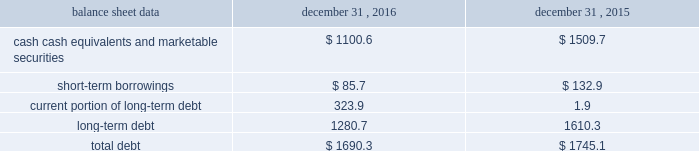Management 2019s discussion and analysis of financial condition and results of operations 2013 ( continued ) ( amounts in millions , except per share amounts ) the effect of foreign exchange rate changes on cash and cash equivalents included in the consolidated statements of cash flows resulted in a decrease of $ 156.1 in 2015 .
The decrease was primarily a result of the u.s .
Dollar being stronger than several foreign currencies , including the australian dollar , brazilian real , canadian dollar , euro and south african rand as of december 31 , 2015 compared to december 31 , 2014. .
Liquidity outlook we expect our cash flow from operations , cash and cash equivalents to be sufficient to meet our anticipated operating requirements at a minimum for the next twelve months .
We also have a committed corporate credit facility as well as uncommitted facilities available to support our operating needs .
We continue to maintain a disciplined approach to managing liquidity , with flexibility over significant uses of cash , including our capital expenditures , cash used for new acquisitions , our common stock repurchase program and our common stock dividends .
From time to time , we evaluate market conditions and financing alternatives for opportunities to raise additional funds or otherwise improve our liquidity profile , enhance our financial flexibility and manage market risk .
Our ability to access the capital markets depends on a number of factors , which include those specific to us , such as our credit rating , and those related to the financial markets , such as the amount or terms of available credit .
There can be no guarantee that we would be able to access new sources of liquidity on commercially reasonable terms , or at all .
Funding requirements our most significant funding requirements include our operations , non-cancelable operating lease obligations , capital expenditures , acquisitions , common stock dividends , taxes and debt service .
Additionally , we may be required to make payments to minority shareholders in certain subsidiaries if they exercise their options to sell us their equity interests .
Notable funding requirements include : 2022 debt service 2013 our 2.25% ( 2.25 % ) senior notes in aggregate principal amount of $ 300.0 mature on november 15 , 2017 , and a $ 22.6 note classified within our other notes payable is due on june 30 , 2017 .
We expect to use available cash to fund the retirement of the outstanding notes upon maturity .
The remainder of our debt is primarily long-term , with maturities scheduled through 2024 .
See the table below for the maturity schedule of our long-term debt .
2022 acquisitions 2013 we paid cash of $ 52.1 , net of cash acquired of $ 13.6 , for acquisitions completed in 2016 .
We also paid $ 0.5 in up-front payments and $ 59.3 in deferred payments for prior-year acquisitions as well as ownership increases in our consolidated subsidiaries .
In addition to potential cash expenditures for new acquisitions , we expect to pay approximately $ 77.0 in 2017 related to prior-year acquisitions .
We may also be required to pay approximately $ 31.0 in 2017 related to put options held by minority shareholders if exercised .
We will continue to evaluate strategic opportunities to grow and continue to strengthen our market position , particularly in our digital and marketing services offerings , and to expand our presence in high-growth and key strategic world markets .
2022 dividends 2013 during 2016 , we paid four quarterly cash dividends of $ 0.15 per share on our common stock , which corresponded to aggregate dividend payments of $ 238.4 .
On february 10 , 2017 , we announced that our board of directors ( the 201cboard 201d ) had declared a common stock cash dividend of $ 0.18 per share , payable on march 15 , 2017 to holders of record as of the close of business on march 1 , 2017 .
Assuming we pay a quarterly dividend of $ 0.18 per share and there is no significant change in the number of outstanding shares as of december 31 , 2016 , we would expect to pay approximately $ 280.0 over the next twelve months. .
What is the net debt if all cash was used to repay debt? 
Computations: (1690.3 - 1100.6)
Answer: 589.7. 